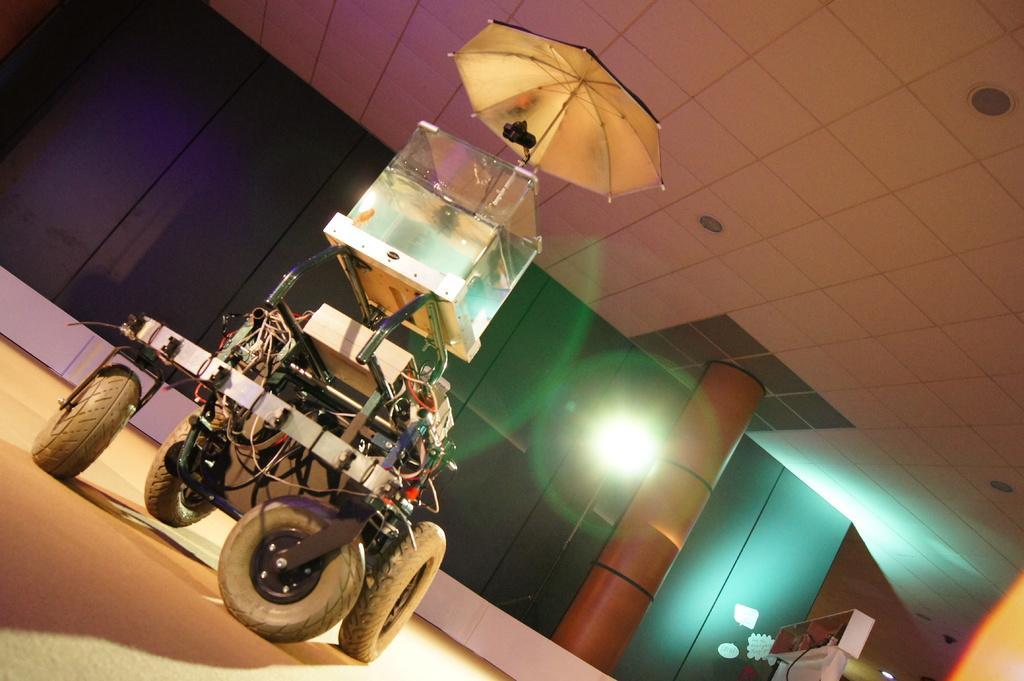Could you give a brief overview of what you see in this image? In a room,there is a machine and it has four wheels and above the machine there is an umbrella and in the background there are purple and green doors with an orange pillar. 